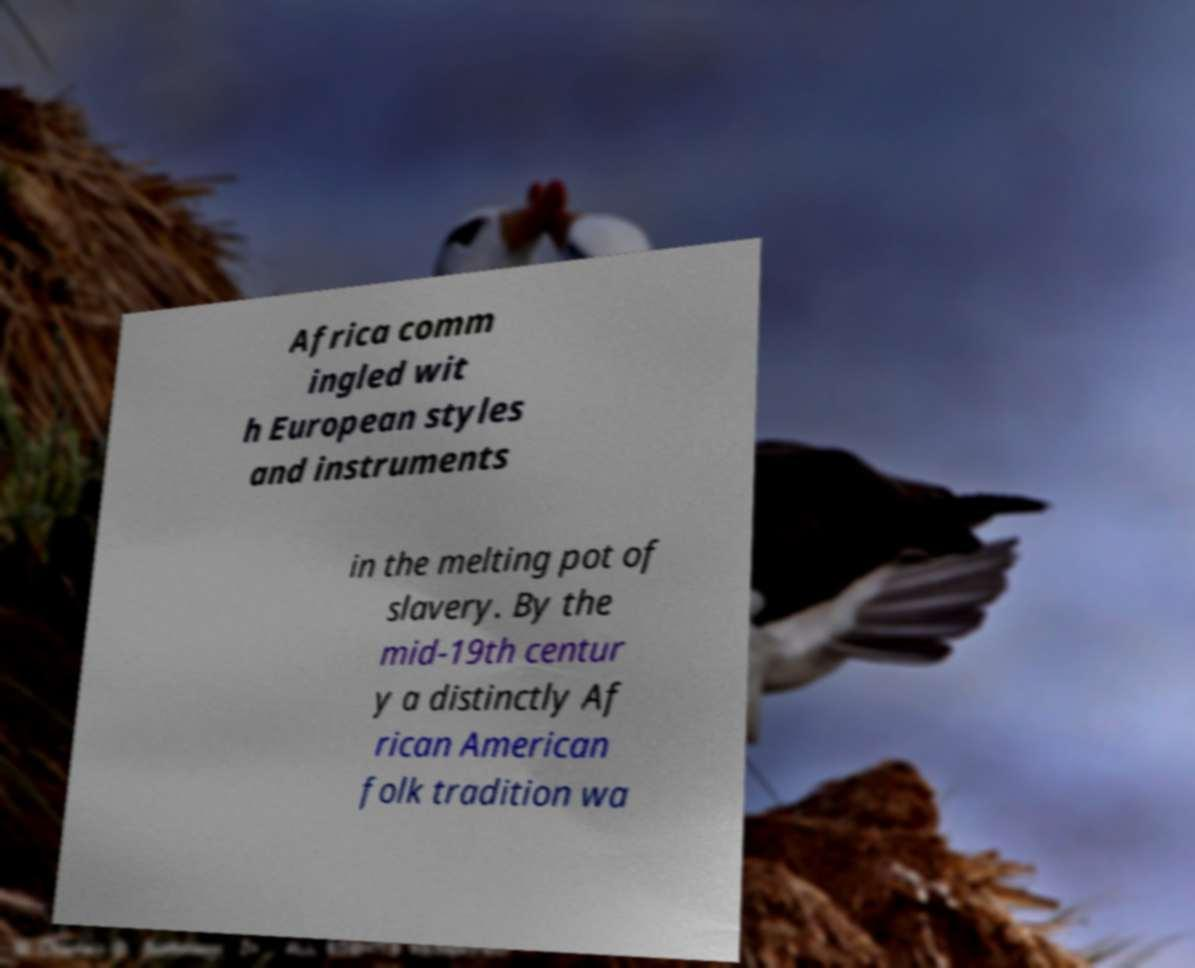Please identify and transcribe the text found in this image. Africa comm ingled wit h European styles and instruments in the melting pot of slavery. By the mid-19th centur y a distinctly Af rican American folk tradition wa 